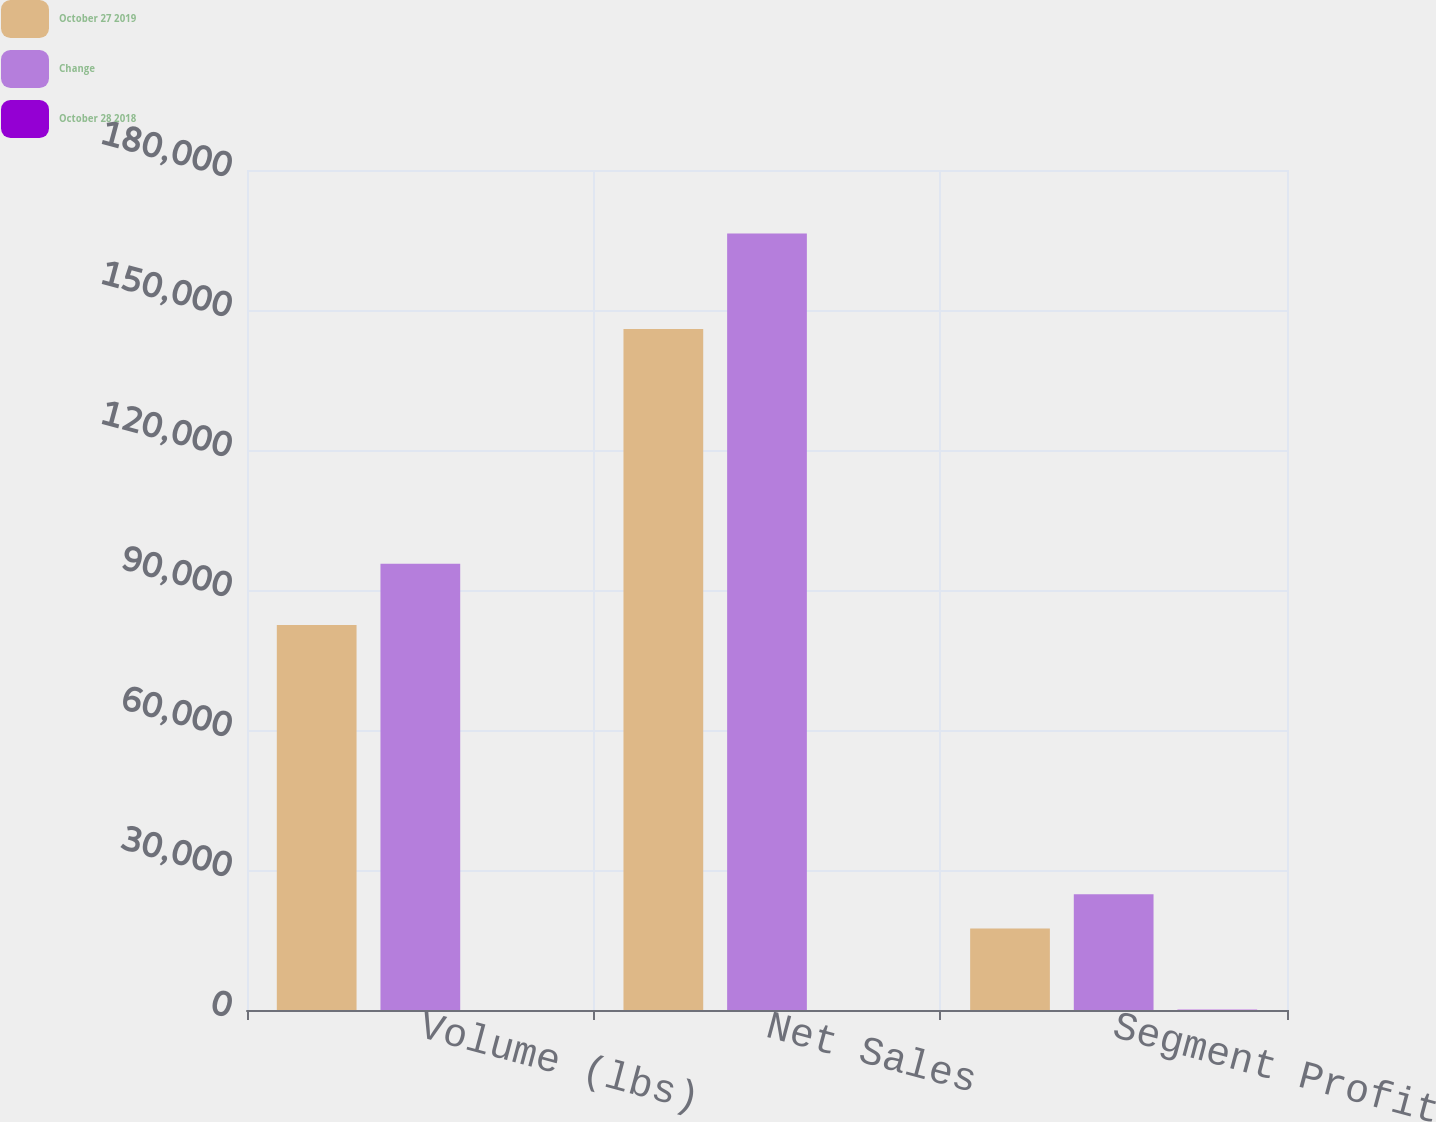Convert chart. <chart><loc_0><loc_0><loc_500><loc_500><stacked_bar_chart><ecel><fcel>Volume (lbs)<fcel>Net Sales<fcel>Segment Profit<nl><fcel>October 27 2019<fcel>82493<fcel>145907<fcel>17455<nl><fcel>Change<fcel>95600<fcel>166391<fcel>24802<nl><fcel>October 28 2018<fcel>13.7<fcel>12.3<fcel>29.6<nl></chart> 